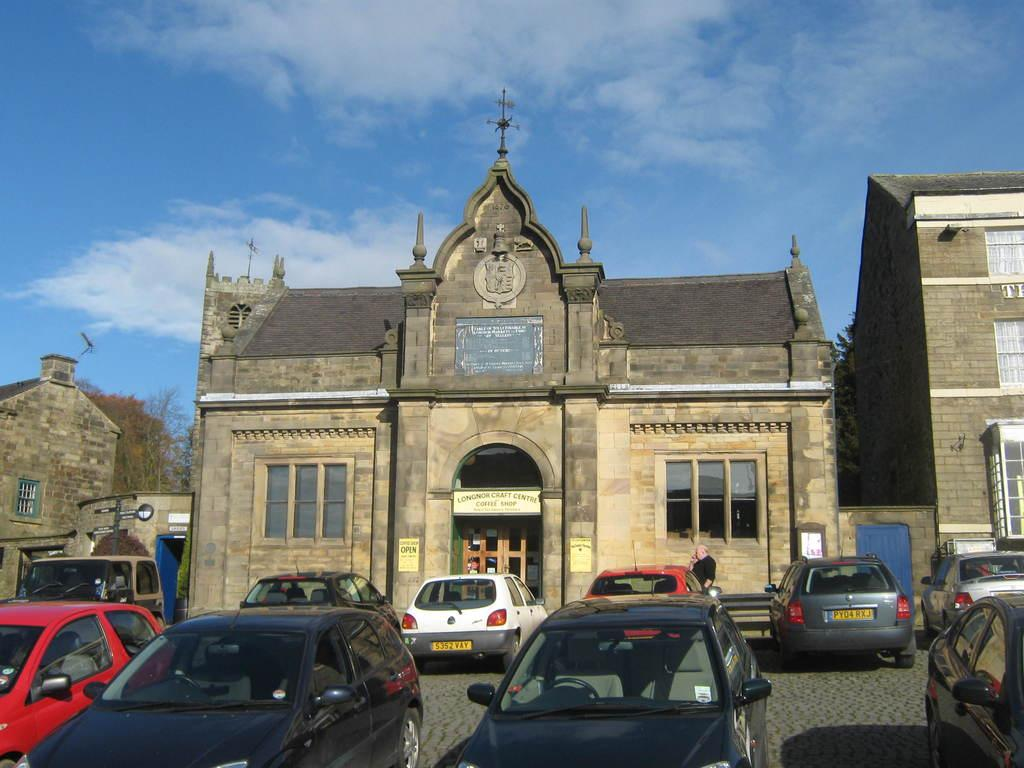What type of vehicles are on the ground in the image? There are cars on the ground in the image. What structures can be seen in the image? There are buildings in the image. What feature is present on the buildings? There are windows visible on the buildings. What type of vegetation is in the image? There are trees in the image. What is visible in the background of the image? The sky is visible in the background of the image. Where is the tub located in the image? There is no tub present in the image. What type of pest can be seen crawling on the buildings in the image? There are no pests visible in the image; only cars, buildings, trees, and the sky are present. 